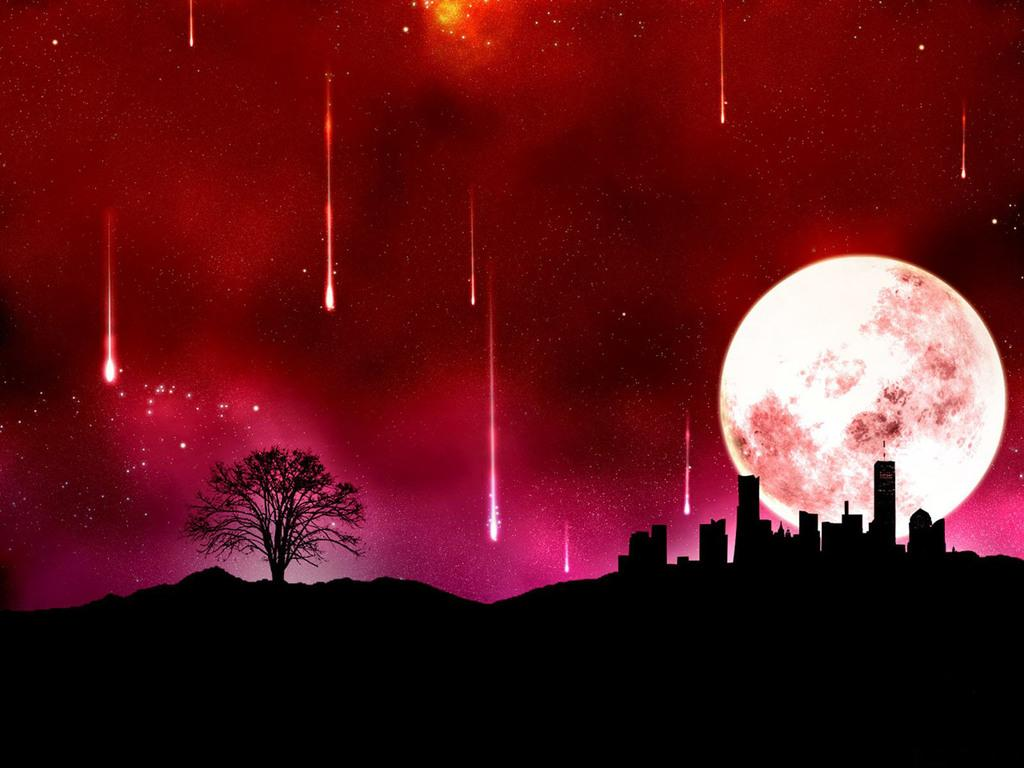What type of natural element can be seen in the image? There is a tree in the image. What type of man-made structures are present in the image? There are buildings in the image. What celestial body is visible in the image? The moon is visible in the image. What is the color of the background in the image? The background of the image has a pinkish color. How does the tree express its feelings of comfort in the image? Trees do not express feelings, as they are inanimate objects. What changes are depicted in the image that show the passage of time? The provided facts do not mention any changes or passage of time in the image. 